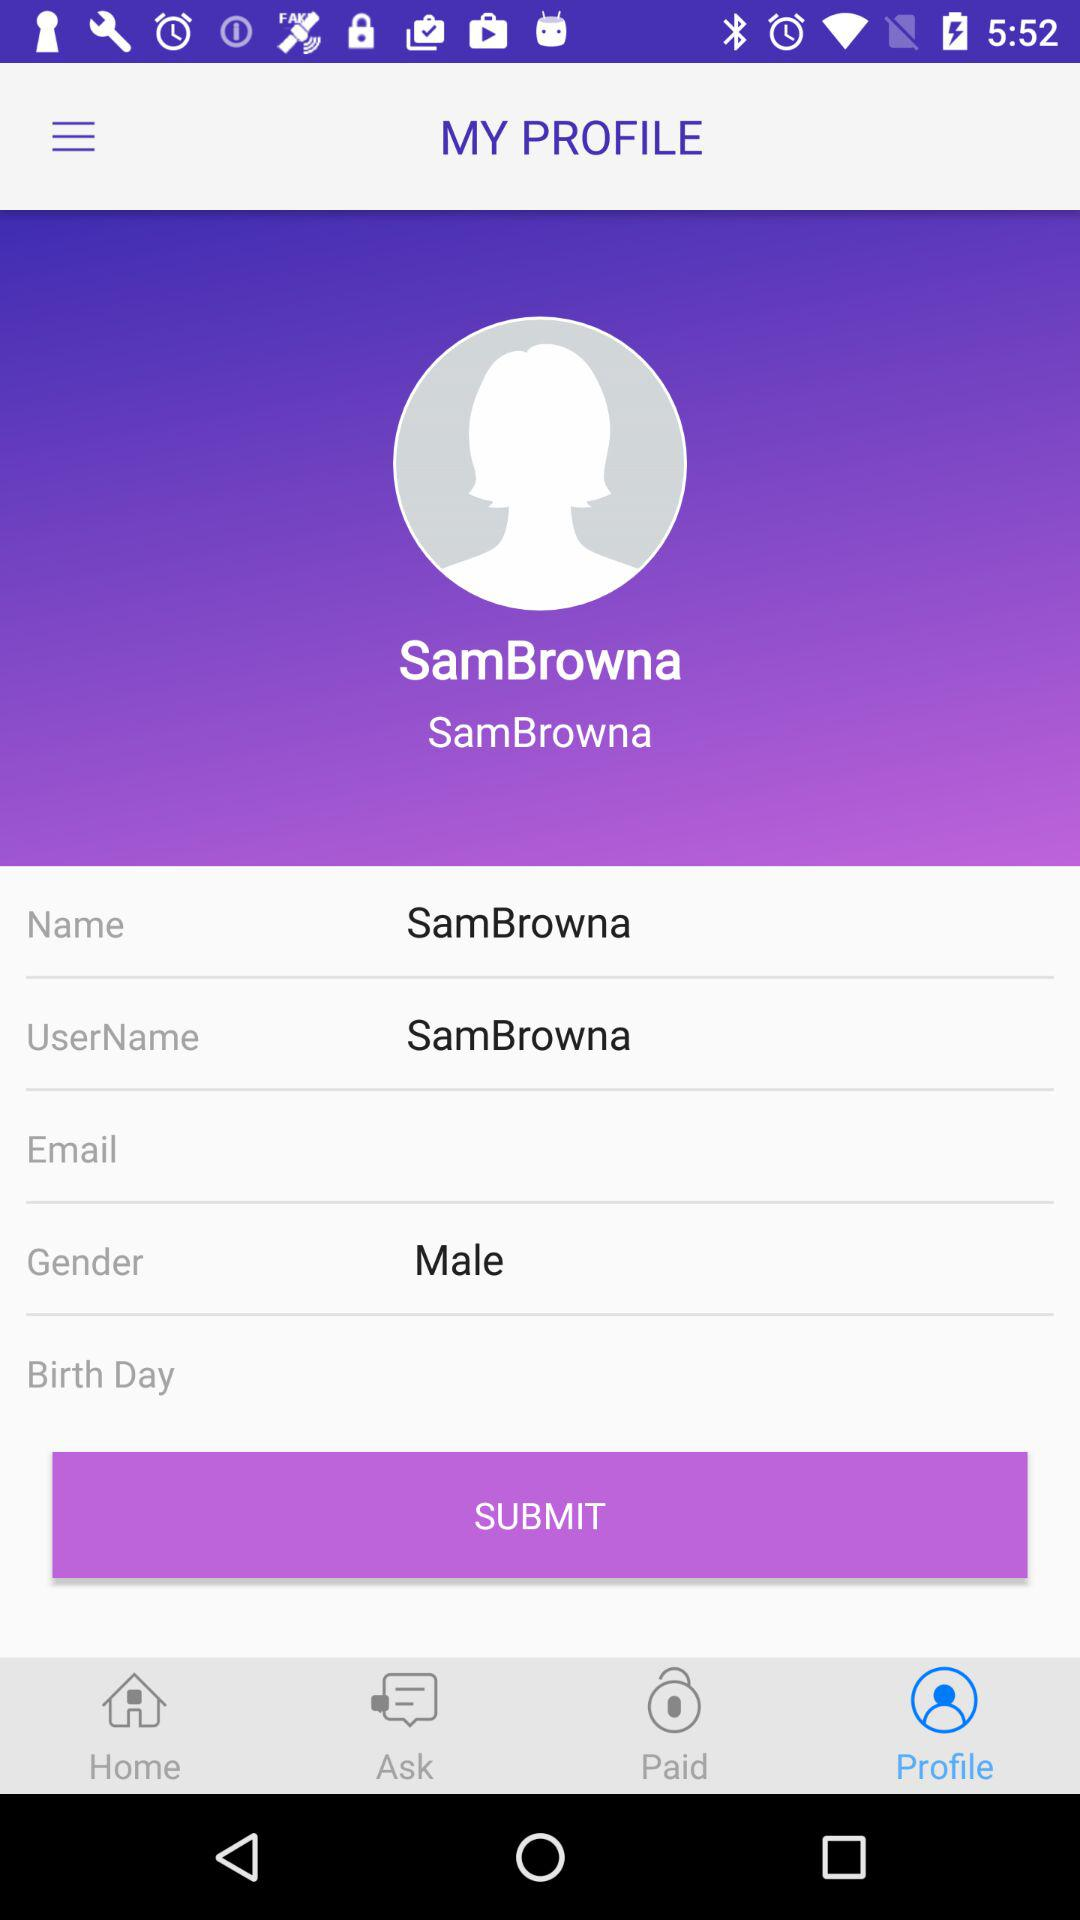What is the given "UserName"? The given "UserName" is "SamBrowna". 